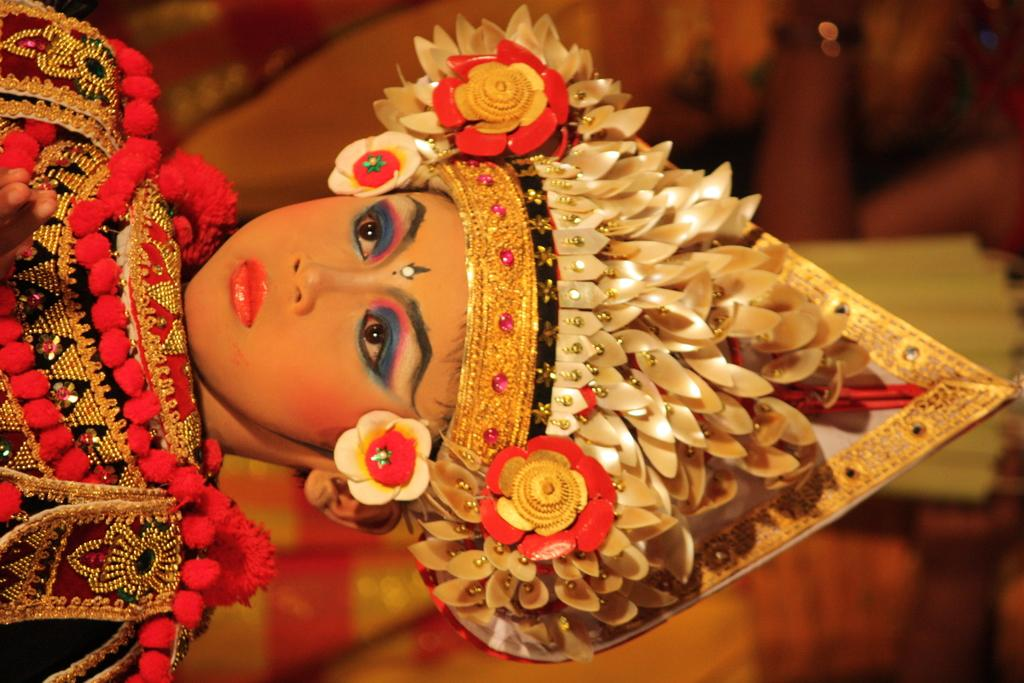Who is the main subject in the picture? There is a girl in the picture. What is the girl wearing? The girl is wearing a fancy dress and a fancy cap on her head. Can you describe the background of the image? The background of the image is blurry. What type of ghost can be seen in the image? There is no ghost present in the image; it features a girl wearing a fancy dress and cap. How does the fog affect the visibility in the image? There is no fog present in the image; the background is simply blurry. 